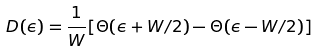Convert formula to latex. <formula><loc_0><loc_0><loc_500><loc_500>D ( \epsilon ) = \frac { 1 } { W } [ \Theta ( \epsilon + W / 2 ) - \Theta ( \epsilon - W / 2 ) ]</formula> 